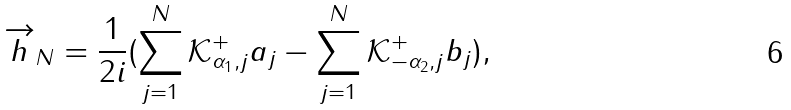Convert formula to latex. <formula><loc_0><loc_0><loc_500><loc_500>\overrightarrow { h } _ { N } = \frac { 1 } { 2 i } ( \sum _ { j = 1 } ^ { N } \mathcal { K } _ { \alpha _ { 1 } , j } ^ { + } a _ { j } - \sum _ { j = 1 } ^ { N } \mathcal { K } _ { - \alpha _ { 2 } , j } ^ { + } b _ { j } ) ,</formula> 